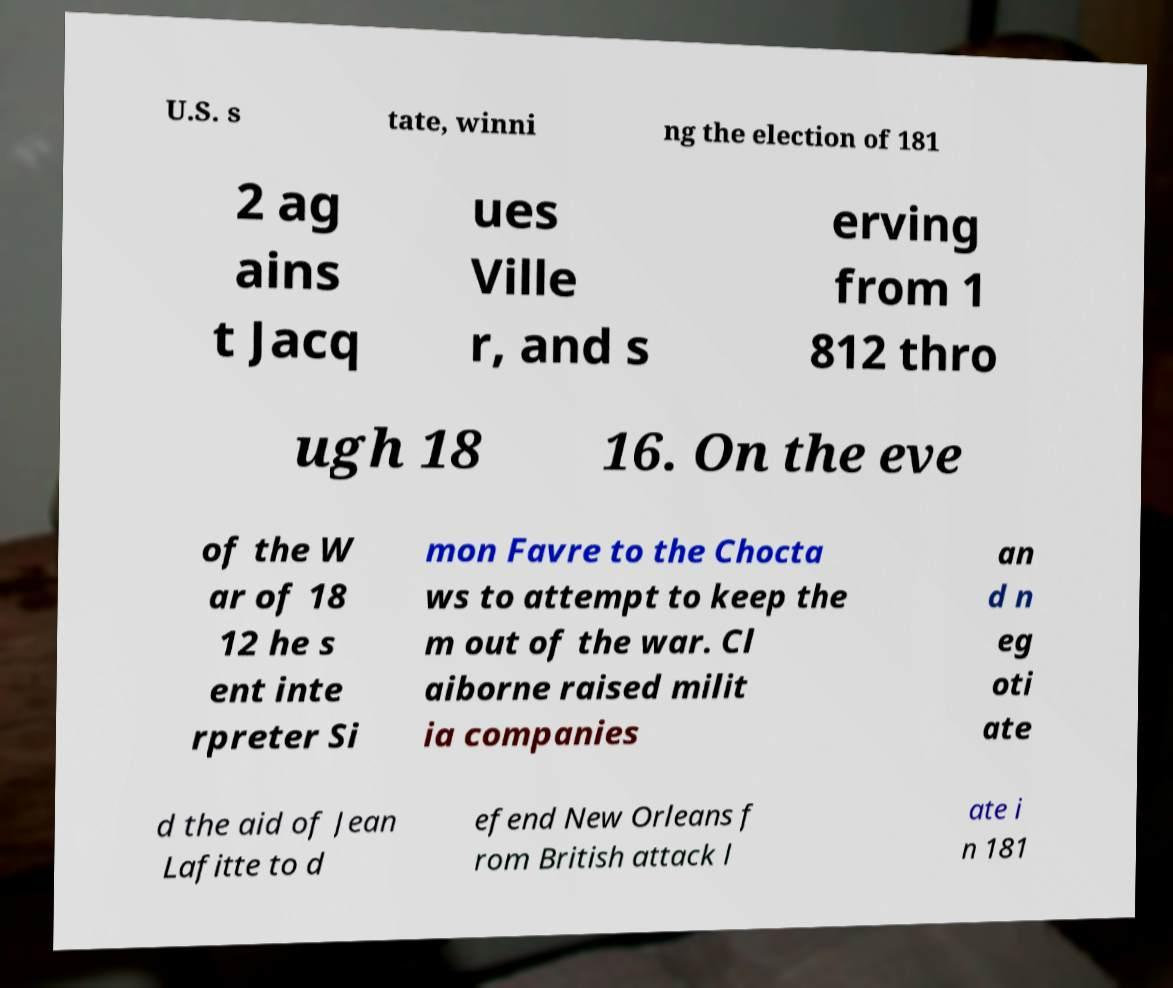Could you extract and type out the text from this image? U.S. s tate, winni ng the election of 181 2 ag ains t Jacq ues Ville r, and s erving from 1 812 thro ugh 18 16. On the eve of the W ar of 18 12 he s ent inte rpreter Si mon Favre to the Chocta ws to attempt to keep the m out of the war. Cl aiborne raised milit ia companies an d n eg oti ate d the aid of Jean Lafitte to d efend New Orleans f rom British attack l ate i n 181 